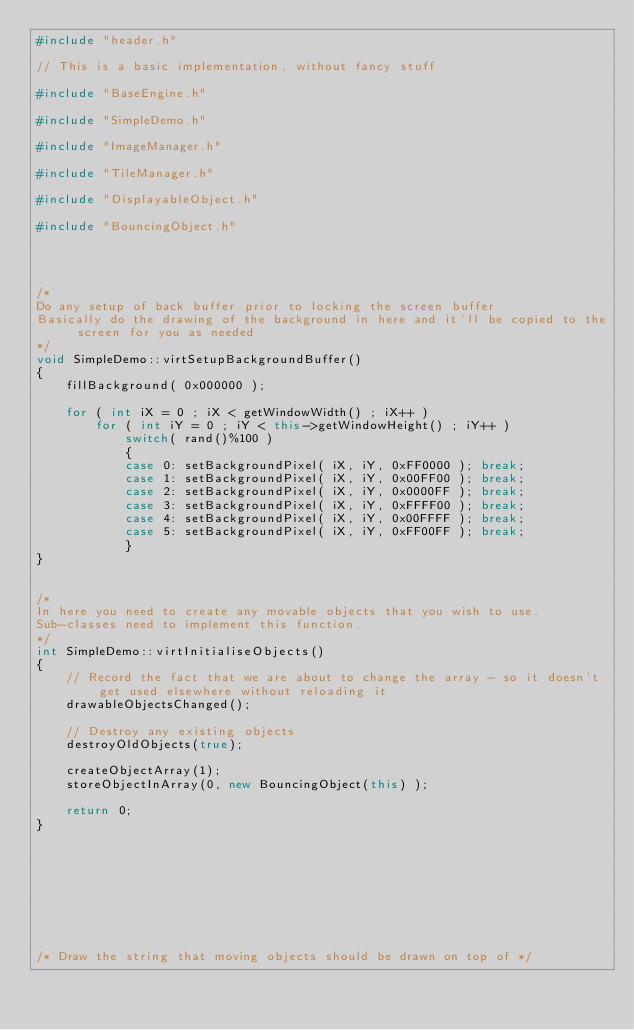<code> <loc_0><loc_0><loc_500><loc_500><_C++_>#include "header.h"

// This is a basic implementation, without fancy stuff

#include "BaseEngine.h"

#include "SimpleDemo.h"

#include "ImageManager.h"

#include "TileManager.h"

#include "DisplayableObject.h"

#include "BouncingObject.h"




/*
Do any setup of back buffer prior to locking the screen buffer
Basically do the drawing of the background in here and it'll be copied to the screen for you as needed
*/
void SimpleDemo::virtSetupBackgroundBuffer()
{
	fillBackground( 0x000000 );

	for ( int iX = 0 ; iX < getWindowWidth() ; iX++ )
		for ( int iY = 0 ; iY < this->getWindowHeight() ; iY++ )
			switch( rand()%100 )
			{
			case 0: setBackgroundPixel( iX, iY, 0xFF0000 ); break;
			case 1: setBackgroundPixel( iX, iY, 0x00FF00 ); break;
			case 2: setBackgroundPixel( iX, iY, 0x0000FF ); break;
			case 3: setBackgroundPixel( iX, iY, 0xFFFF00 ); break;
			case 4: setBackgroundPixel( iX, iY, 0x00FFFF ); break;
			case 5: setBackgroundPixel( iX, iY, 0xFF00FF ); break;
			}
}


/*
In here you need to create any movable objects that you wish to use.
Sub-classes need to implement this function.
*/
int SimpleDemo::virtInitialiseObjects()
{
	// Record the fact that we are about to change the array - so it doesn't get used elsewhere without reloading it
	drawableObjectsChanged();

	// Destroy any existing objects
	destroyOldObjects(true);

	createObjectArray(1);
	storeObjectInArray(0, new BouncingObject(this) );

	return 0;
}









/* Draw the string that moving objects should be drawn on top of */</code> 